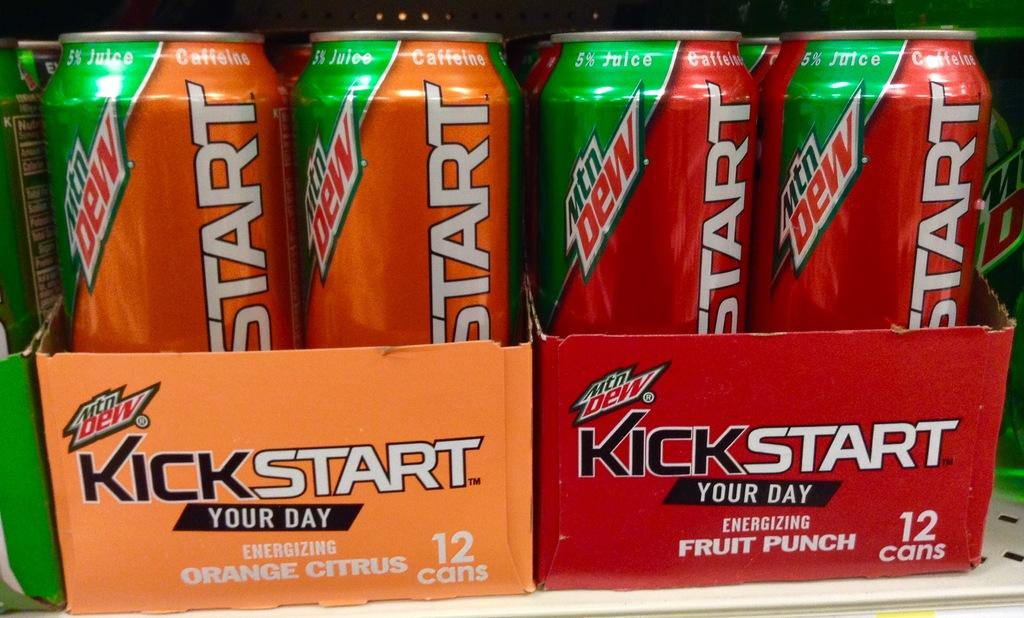<image>
Present a compact description of the photo's key features. a couple cardboard containers that say Kickstart on them 